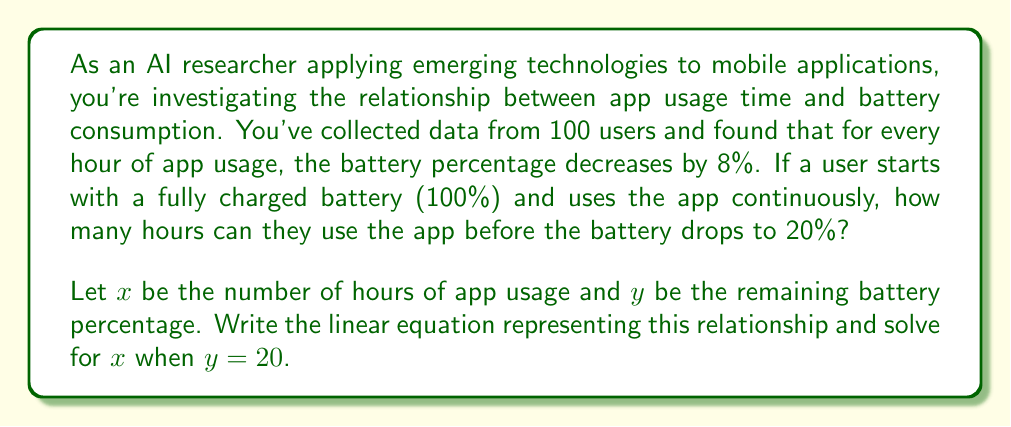Could you help me with this problem? To solve this problem, we'll follow these steps:

1. Formulate the linear equation:
   The general form of a linear equation is $y = mx + b$, where $m$ is the slope and $b$ is the y-intercept.

   In this case:
   - The y-intercept (b) is 100%, as the battery starts fully charged.
   - The slope (m) is -8, as the battery decreases by 8% per hour.

   So, our equation is:
   $$y = -8x + 100$$

2. Substitute the known values:
   We want to find $x$ when $y = 20$, so we substitute this into our equation:
   $$20 = -8x + 100$$

3. Solve for $x$:
   $$20 - 100 = -8x$$
   $$-80 = -8x$$
   $$x = \frac{-80}{-8} = 10$$

Therefore, the user can use the app for 10 hours before the battery drops to 20%.

To verify:
Initial battery: 100%
After 10 hours: $100 - (8 * 10) = 100 - 80 = 20\%$
Answer: The user can use the app for 10 hours before the battery drops to 20%. 